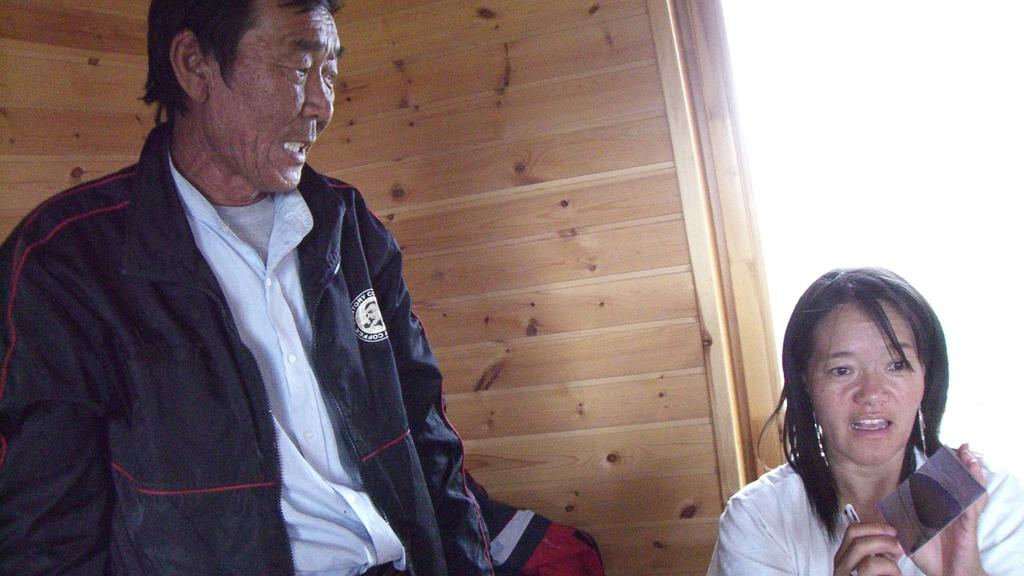What is the gender of the person standing in the image? There is a man standing in the image. Are there any other people in the image? Yes, there is a woman in the image. What is the woman holding in her hand? The woman is holding objects in her hand. What can be seen in the background of the image? There is a wooden wall in the background of the image. What type of lead is the man using to communicate with the goldfish in the image? There is no lead or goldfish present in the image. 